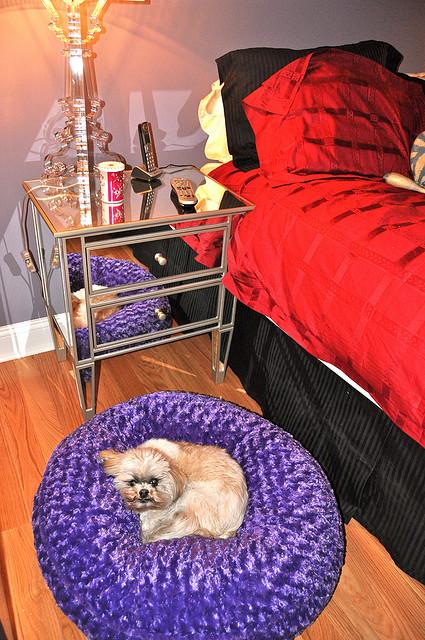How many beds are there?
Concise answer only. 2. Is there a phone on the table?
Keep it brief. Yes. Is the dog comfortable?
Concise answer only. Yes. 